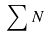<formula> <loc_0><loc_0><loc_500><loc_500>\sum { N }</formula> 